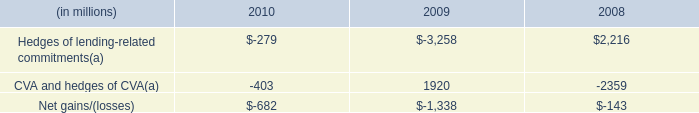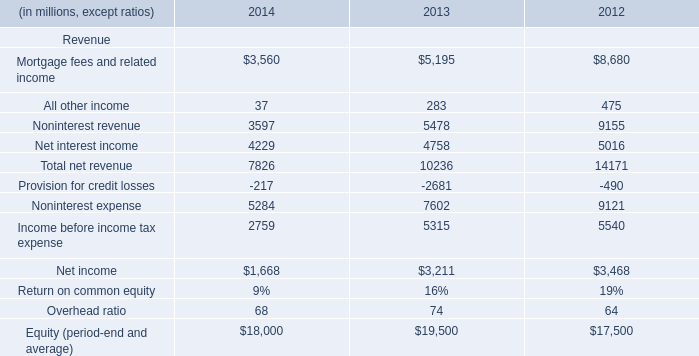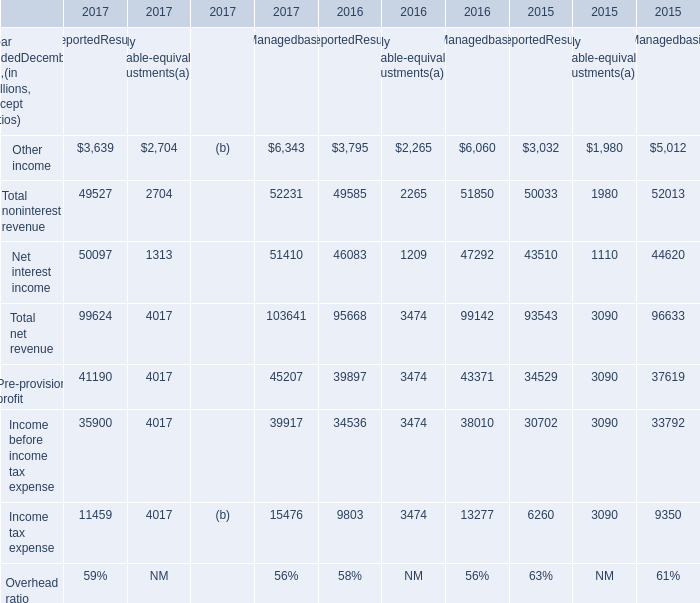what was the annual decline in wholesale lending-related commitments in 2010? 
Computations: ((346.1 - 347.2) / 347.2)
Answer: -0.00317. 